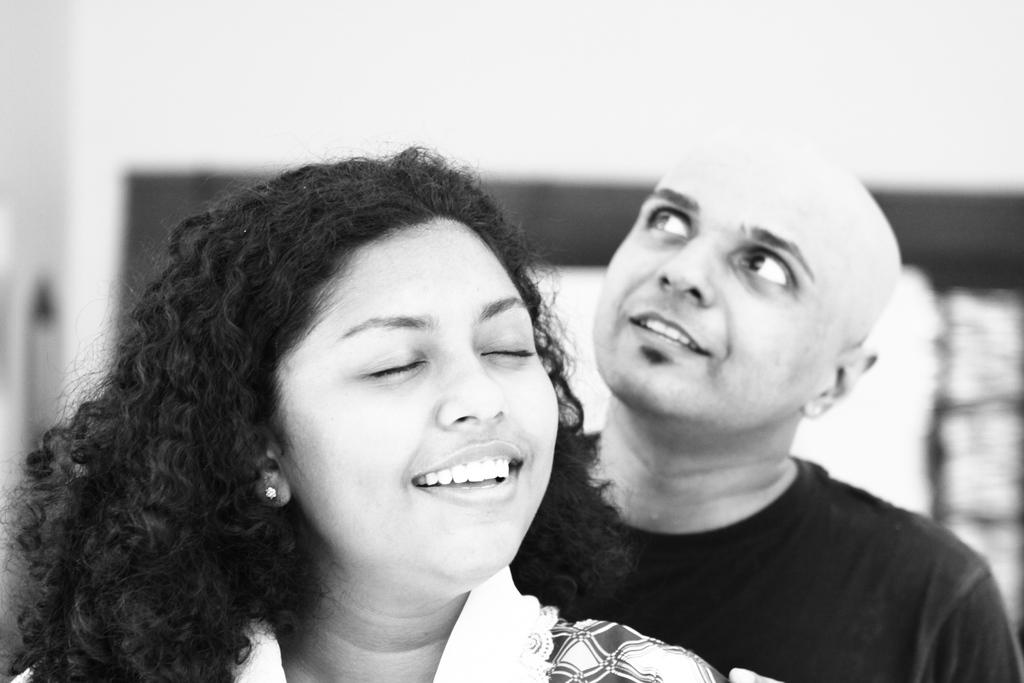What is the color scheme of the image? The image is black and white. Who is present in the image? There is a woman in the image, and a man is behind her. Can you describe the background of the image? The background of the image is blurred, and there is a wall visible. What else can be seen in the background of the image? There are objects visible in the background. What type of drain is visible in the image? There is no drain present in the image. What kind of machine can be seen in the background of the image? There is no machine visible in the image. 